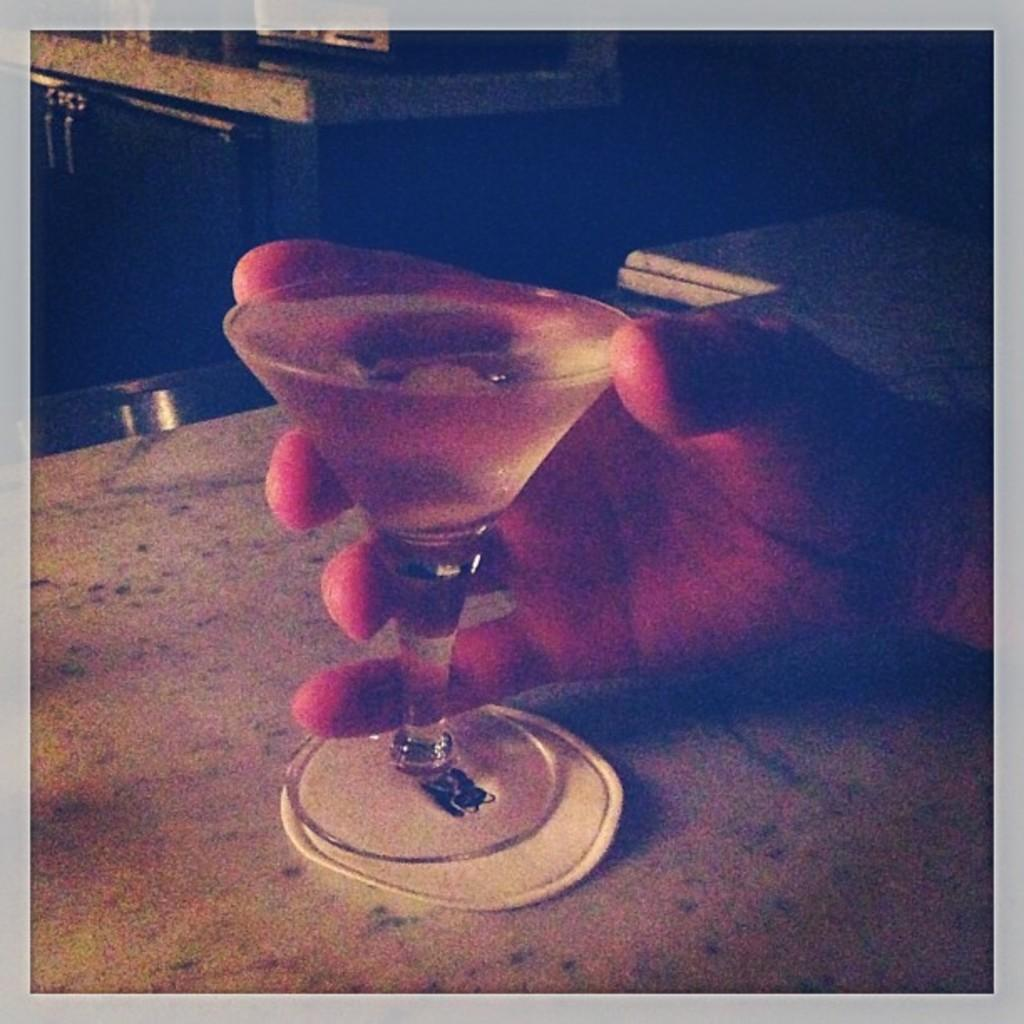What is in the glass that is visible in the image? There is a drink in the cocktail glass in the image. Who is holding the glass in the image? A person is holding the glass in the image. Where is the glass placed when it is not being held? The glass is placed on a table when it is not being held. What type of skin can be seen on the giants in the image? There are no giants present in the image, so there is no skin to observe. 